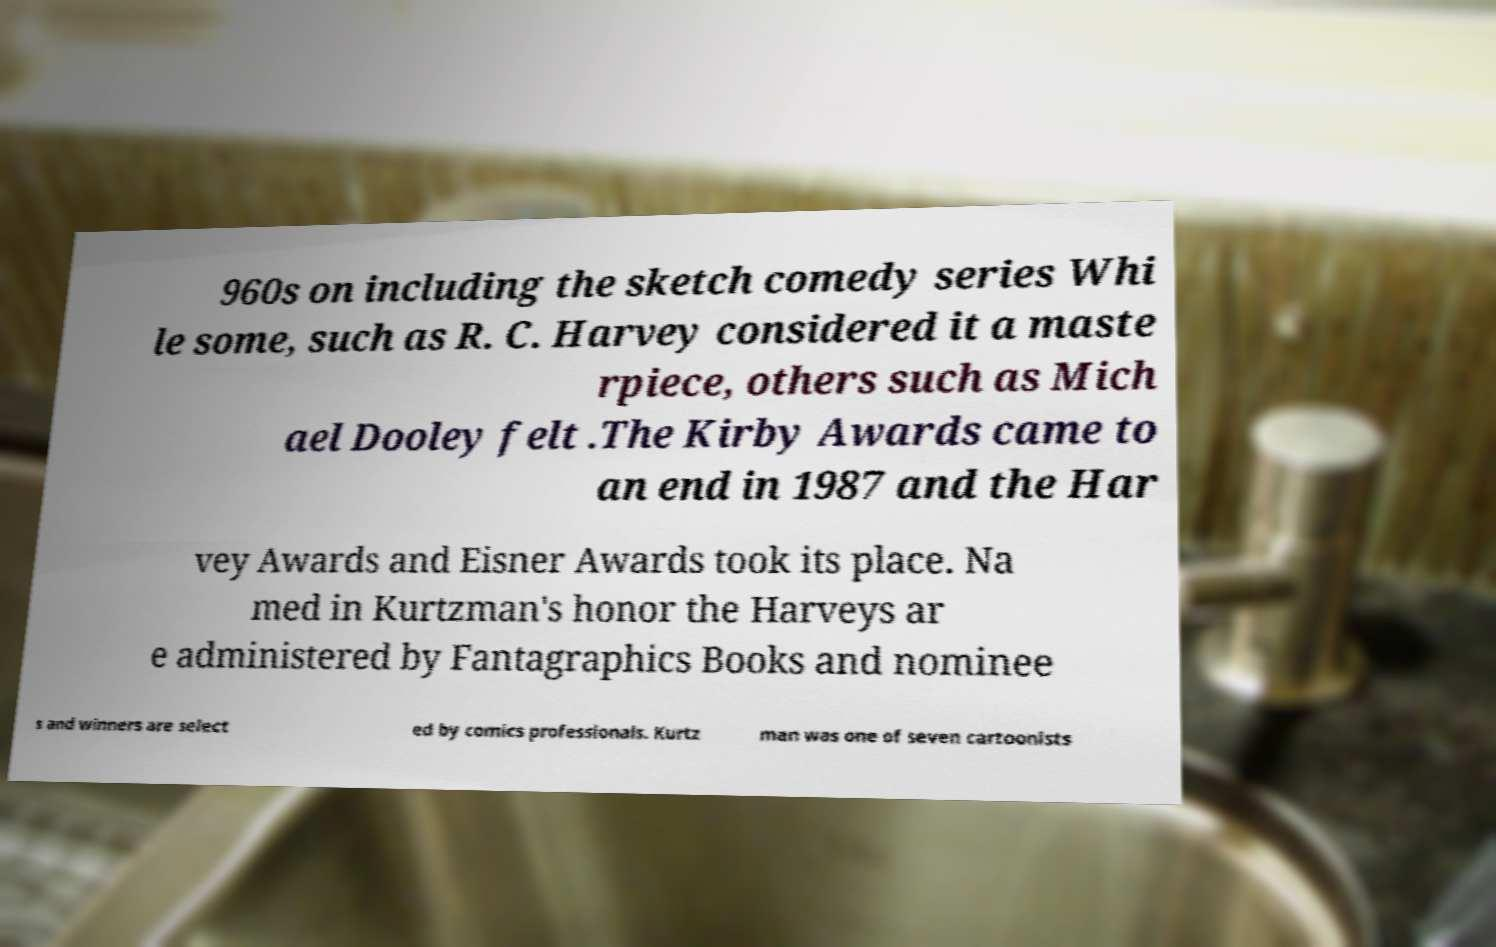Could you extract and type out the text from this image? 960s on including the sketch comedy series Whi le some, such as R. C. Harvey considered it a maste rpiece, others such as Mich ael Dooley felt .The Kirby Awards came to an end in 1987 and the Har vey Awards and Eisner Awards took its place. Na med in Kurtzman's honor the Harveys ar e administered by Fantagraphics Books and nominee s and winners are select ed by comics professionals. Kurtz man was one of seven cartoonists 